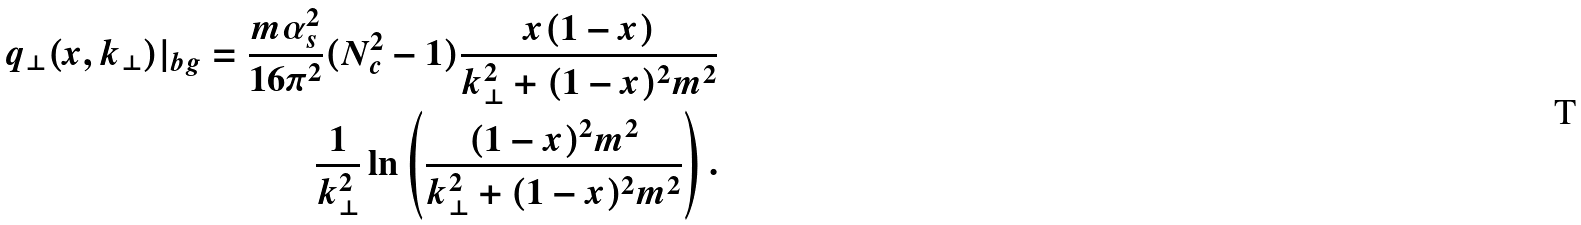Convert formula to latex. <formula><loc_0><loc_0><loc_500><loc_500>q _ { \perp } ( x , k _ { \perp } ) | _ { b g } = \frac { m \alpha _ { s } ^ { 2 } } { 1 6 \pi ^ { 2 } } ( N _ { c } ^ { 2 } - 1 ) \frac { x ( 1 - x ) } { k ^ { 2 } _ { \perp } + ( 1 - x ) ^ { 2 } m ^ { 2 } } \\ \frac { 1 } { k ^ { 2 } _ { \perp } } \ln \left ( \frac { ( 1 - x ) ^ { 2 } m ^ { 2 } } { k ^ { 2 } _ { \perp } + ( 1 - x ) ^ { 2 } m ^ { 2 } } \right ) .</formula> 